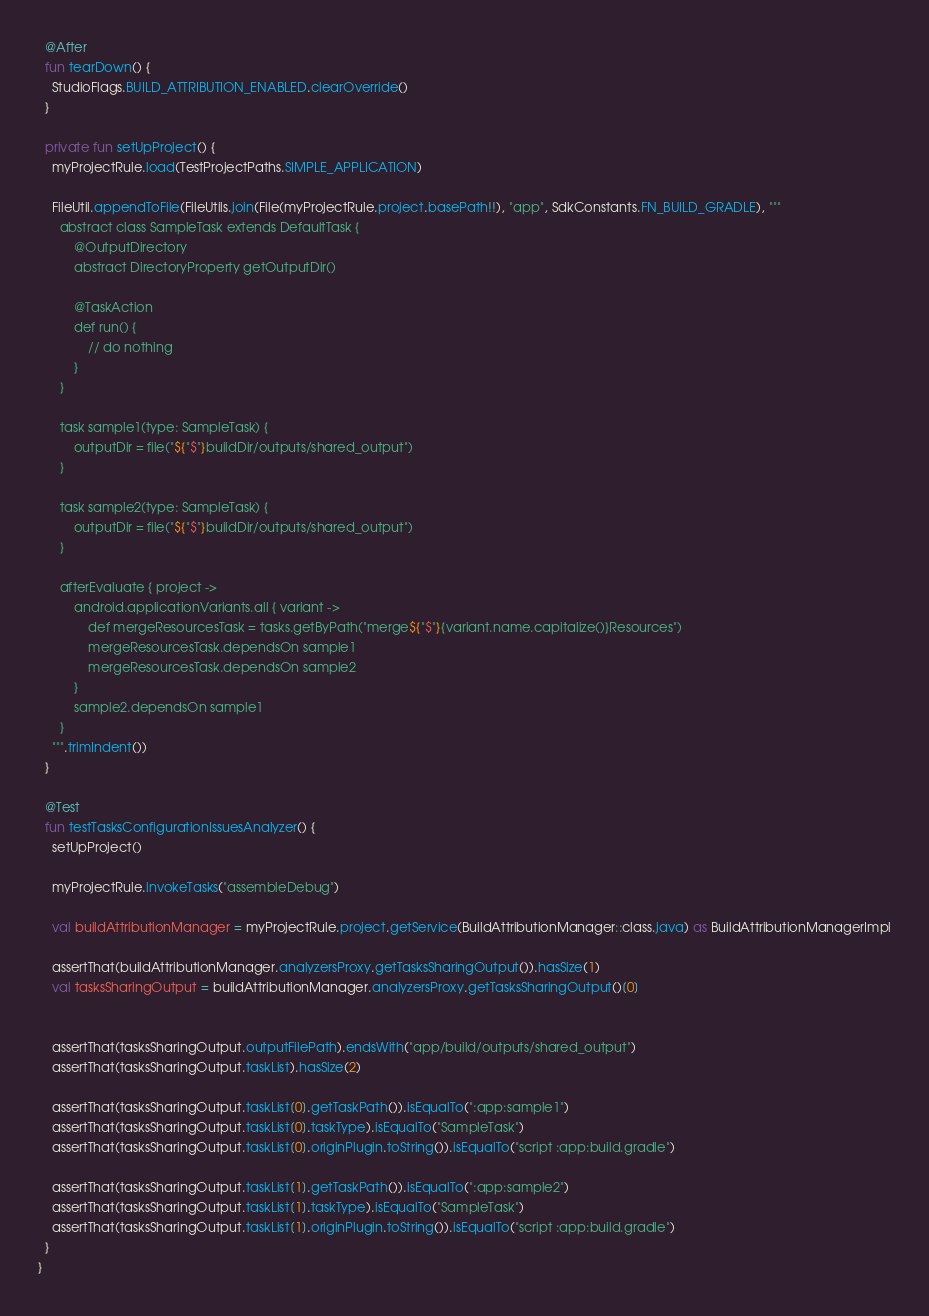<code> <loc_0><loc_0><loc_500><loc_500><_Kotlin_>  @After
  fun tearDown() {
    StudioFlags.BUILD_ATTRIBUTION_ENABLED.clearOverride()
  }

  private fun setUpProject() {
    myProjectRule.load(TestProjectPaths.SIMPLE_APPLICATION)

    FileUtil.appendToFile(FileUtils.join(File(myProjectRule.project.basePath!!), "app", SdkConstants.FN_BUILD_GRADLE), """
      abstract class SampleTask extends DefaultTask {
          @OutputDirectory
          abstract DirectoryProperty getOutputDir()

          @TaskAction
          def run() {
              // do nothing
          }
      }

      task sample1(type: SampleTask) {
          outputDir = file("${"$"}buildDir/outputs/shared_output")
      }

      task sample2(type: SampleTask) {
          outputDir = file("${"$"}buildDir/outputs/shared_output")
      }

      afterEvaluate { project ->
          android.applicationVariants.all { variant ->
              def mergeResourcesTask = tasks.getByPath("merge${"$"}{variant.name.capitalize()}Resources")
              mergeResourcesTask.dependsOn sample1
              mergeResourcesTask.dependsOn sample2
          }
          sample2.dependsOn sample1
      }
    """.trimIndent())
  }

  @Test
  fun testTasksConfigurationIssuesAnalyzer() {
    setUpProject()

    myProjectRule.invokeTasks("assembleDebug")

    val buildAttributionManager = myProjectRule.project.getService(BuildAttributionManager::class.java) as BuildAttributionManagerImpl

    assertThat(buildAttributionManager.analyzersProxy.getTasksSharingOutput()).hasSize(1)
    val tasksSharingOutput = buildAttributionManager.analyzersProxy.getTasksSharingOutput()[0]


    assertThat(tasksSharingOutput.outputFilePath).endsWith("app/build/outputs/shared_output")
    assertThat(tasksSharingOutput.taskList).hasSize(2)

    assertThat(tasksSharingOutput.taskList[0].getTaskPath()).isEqualTo(":app:sample1")
    assertThat(tasksSharingOutput.taskList[0].taskType).isEqualTo("SampleTask")
    assertThat(tasksSharingOutput.taskList[0].originPlugin.toString()).isEqualTo("script :app:build.gradle")

    assertThat(tasksSharingOutput.taskList[1].getTaskPath()).isEqualTo(":app:sample2")
    assertThat(tasksSharingOutput.taskList[1].taskType).isEqualTo("SampleTask")
    assertThat(tasksSharingOutput.taskList[1].originPlugin.toString()).isEqualTo("script :app:build.gradle")
  }
}</code> 